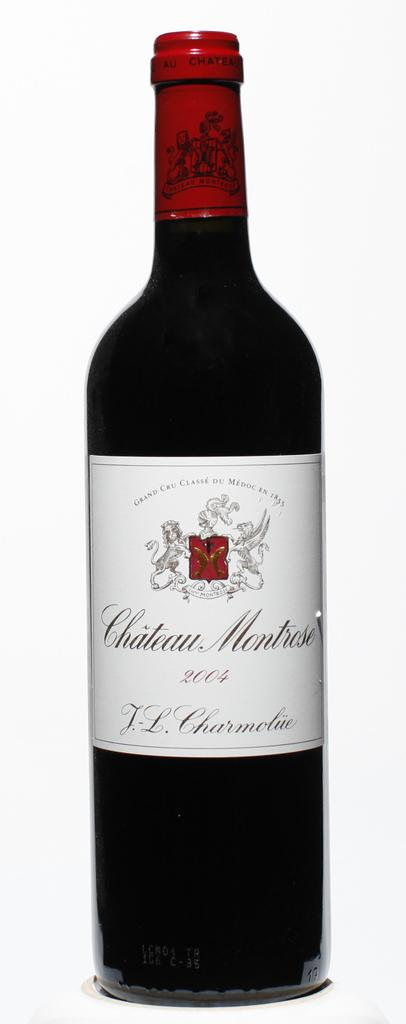<image>
Relay a brief, clear account of the picture shown. A bottle of Chateau Montrose from 2004 has a red crest on the label. 